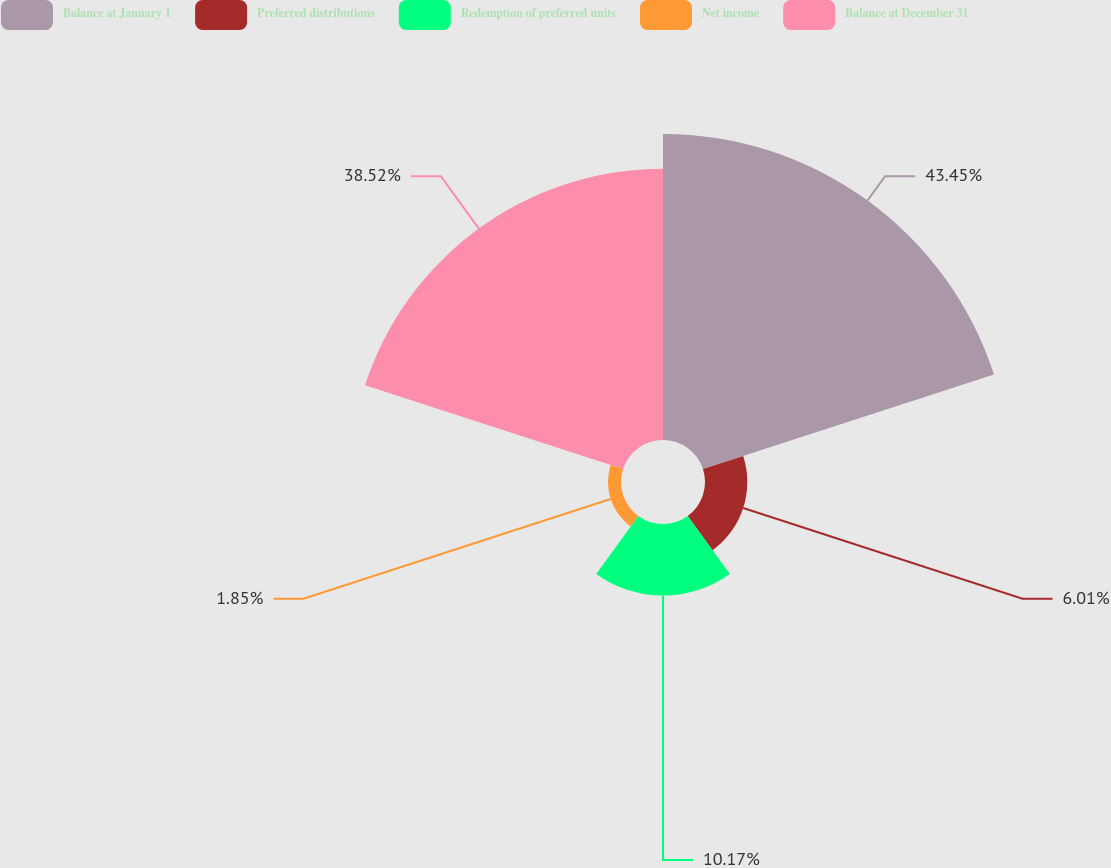Convert chart to OTSL. <chart><loc_0><loc_0><loc_500><loc_500><pie_chart><fcel>Balance at January 1<fcel>Preferred distributions<fcel>Redemption of preferred units<fcel>Net income<fcel>Balance at December 31<nl><fcel>43.45%<fcel>6.01%<fcel>10.17%<fcel>1.85%<fcel>38.52%<nl></chart> 